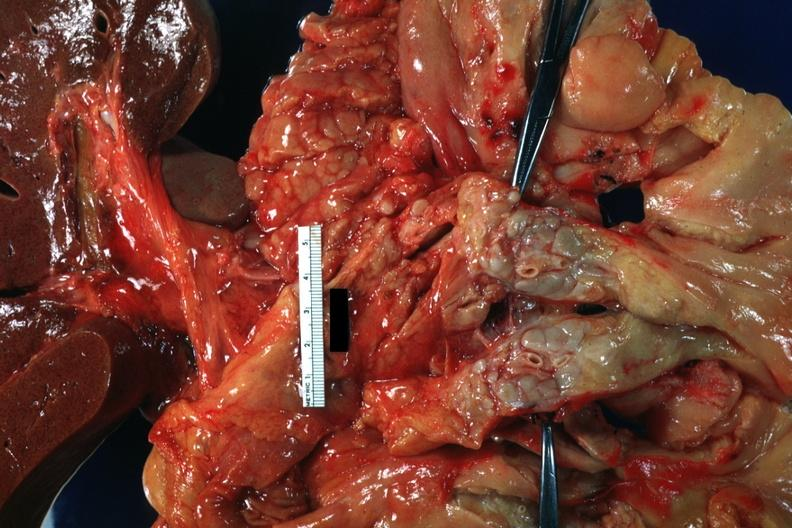what does this image show?
Answer the question using a single word or phrase. Nodes around superior mesenteric artery 